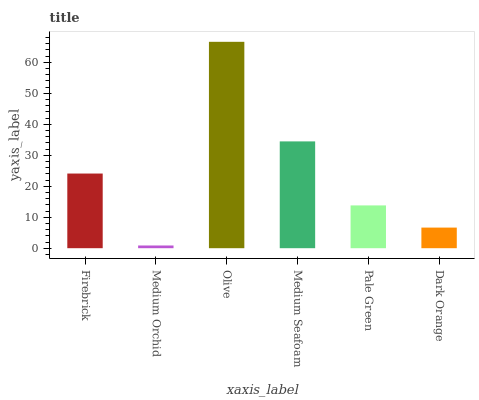Is Medium Orchid the minimum?
Answer yes or no. Yes. Is Olive the maximum?
Answer yes or no. Yes. Is Olive the minimum?
Answer yes or no. No. Is Medium Orchid the maximum?
Answer yes or no. No. Is Olive greater than Medium Orchid?
Answer yes or no. Yes. Is Medium Orchid less than Olive?
Answer yes or no. Yes. Is Medium Orchid greater than Olive?
Answer yes or no. No. Is Olive less than Medium Orchid?
Answer yes or no. No. Is Firebrick the high median?
Answer yes or no. Yes. Is Pale Green the low median?
Answer yes or no. Yes. Is Medium Seafoam the high median?
Answer yes or no. No. Is Medium Seafoam the low median?
Answer yes or no. No. 